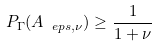<formula> <loc_0><loc_0><loc_500><loc_500>P _ { \Gamma } ( A _ { \ e p s , \nu } ) \geq \frac { 1 } { 1 + \nu }</formula> 